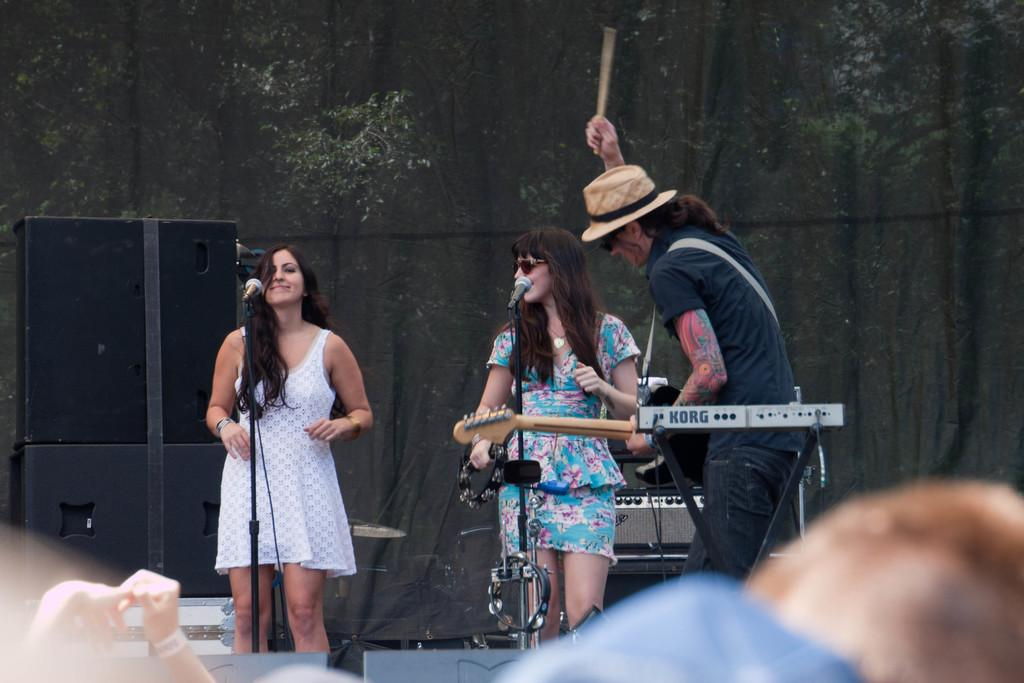What type of band is performing in the image? There is a rock band performing in the image. Where is the rock band performing? The rock band is performing on a stage. What type of scissors are being used by the lead singer during the performance? There are no scissors visible in the image, and the lead singer is not using any during the performance. 